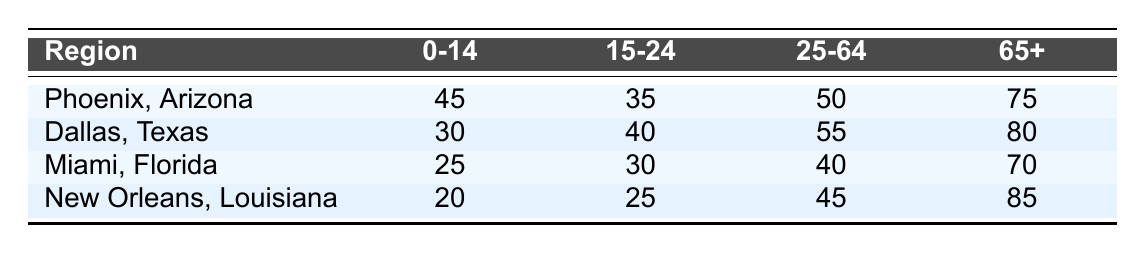What is the incidence of heat-related illnesses for the age group 25-64 in Dallas, Texas? From the row corresponding to Dallas, Texas, in the age group 25-64, the incidence is listed as 55.
Answer: 55 Which region has the highest incidence of heat-related illnesses among individuals aged 65 and older? By examining the last column for the 65+ age group across all regions, New Orleans, Louisiana with an incidence of 85 has the highest value.
Answer: New Orleans, Louisiana What is the total incidence of heat-related illnesses for the age group 0-14 across all regions? Adding the incidences for the 0-14 age group from each region: 45 (Phoenix) + 30 (Dallas) + 25 (Miami) + 20 (New Orleans) = 120.
Answer: 120 Is the incidence of heat-related illnesses for the age group 15-24 in Miami, Florida higher than in Phoenix, Arizona? The incidence in Miami for age group 15-24 is 30, while in Phoenix it is 35. Since 30 is less than 35, the statement is false.
Answer: No Which age group has the lowest incidence of heat-related illnesses in New Orleans, Louisiana? Looking at the incidences in New Orleans, the 0-14 age group has the lowest incidence of 20 when compared to the others: 25 (15-24), 45 (25-64), and 85 (65+).
Answer: 0-14 